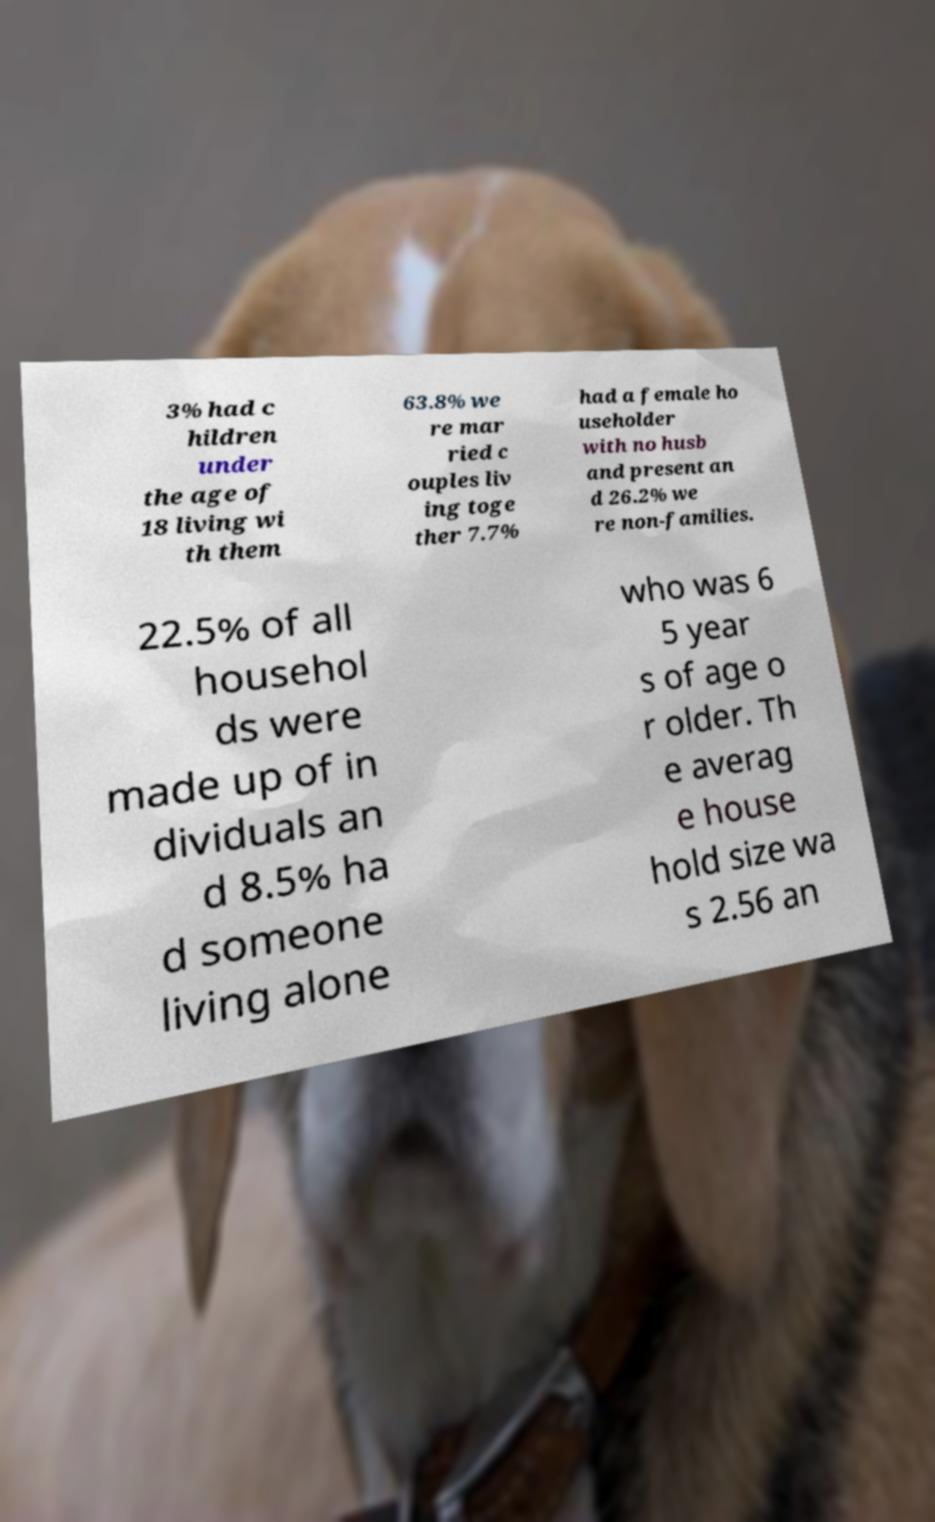Can you read and provide the text displayed in the image?This photo seems to have some interesting text. Can you extract and type it out for me? 3% had c hildren under the age of 18 living wi th them 63.8% we re mar ried c ouples liv ing toge ther 7.7% had a female ho useholder with no husb and present an d 26.2% we re non-families. 22.5% of all househol ds were made up of in dividuals an d 8.5% ha d someone living alone who was 6 5 year s of age o r older. Th e averag e house hold size wa s 2.56 an 